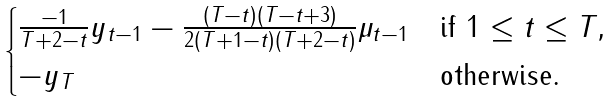<formula> <loc_0><loc_0><loc_500><loc_500>\begin{cases} \frac { - 1 } { T + 2 - t } y _ { t - 1 } - \frac { ( T - t ) ( T - t + 3 ) } { 2 ( T + 1 - t ) ( T + 2 - t ) } \mu _ { t - 1 } & \text {if $1 \leq t \leq T$,} \\ - y _ { T } & \text {otherwise.} \end{cases}</formula> 